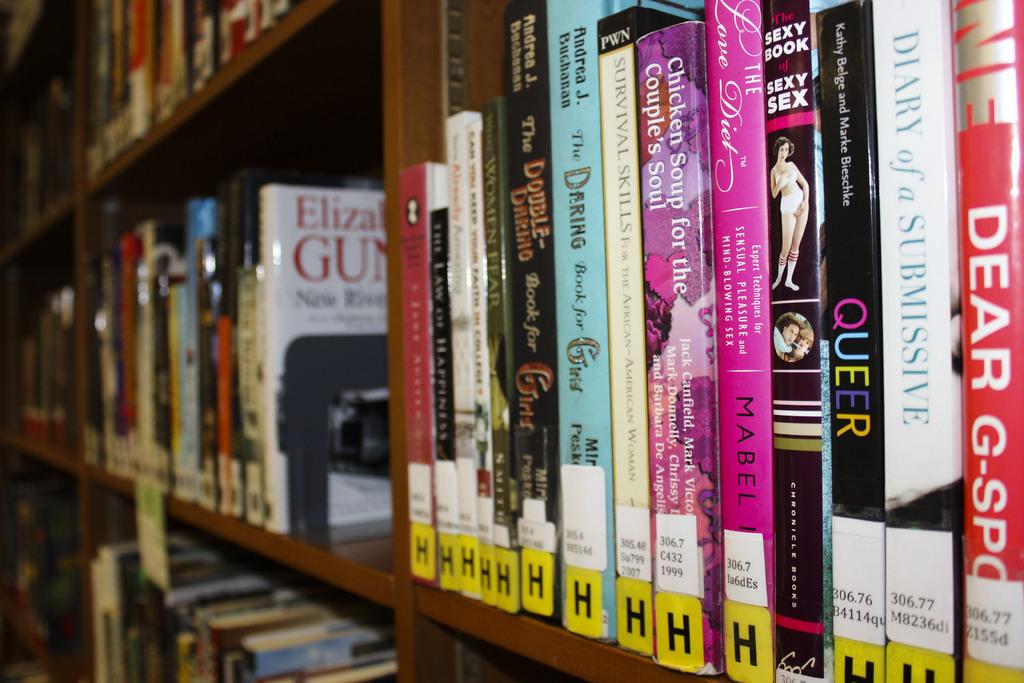What is the name of the white book on the left?
Make the answer very short. Unanswerable. What is the name of the red book on the right?
Your answer should be compact. Dear g-spot. 